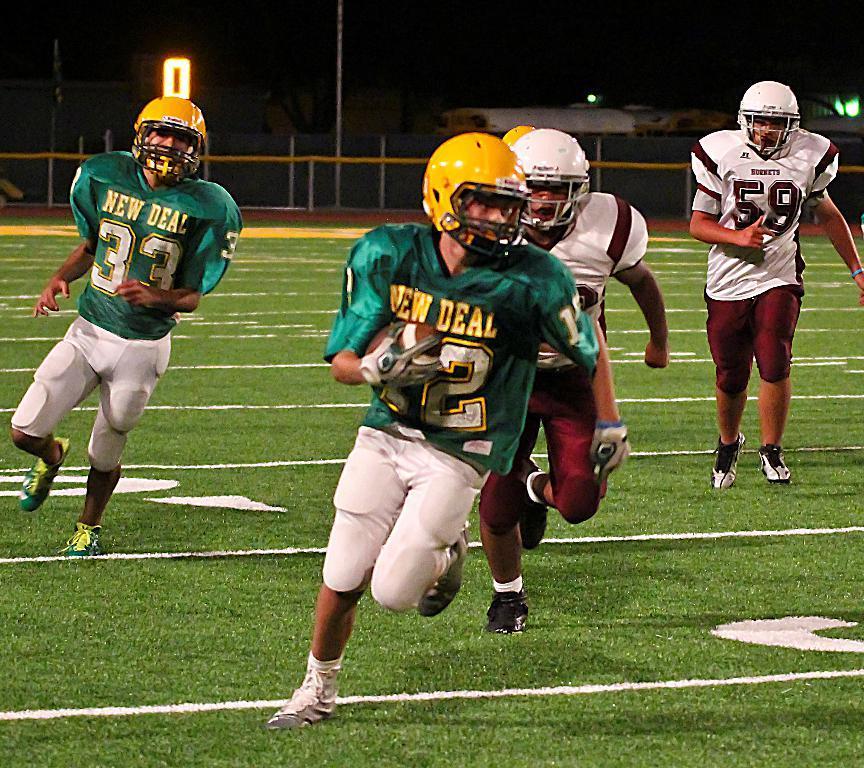Describe this image in one or two sentences. In this picture we can see some people are playing and wearing the sports dress, helmets, shoes. In the background of the image we can see the ground, railing, lights, pole. 